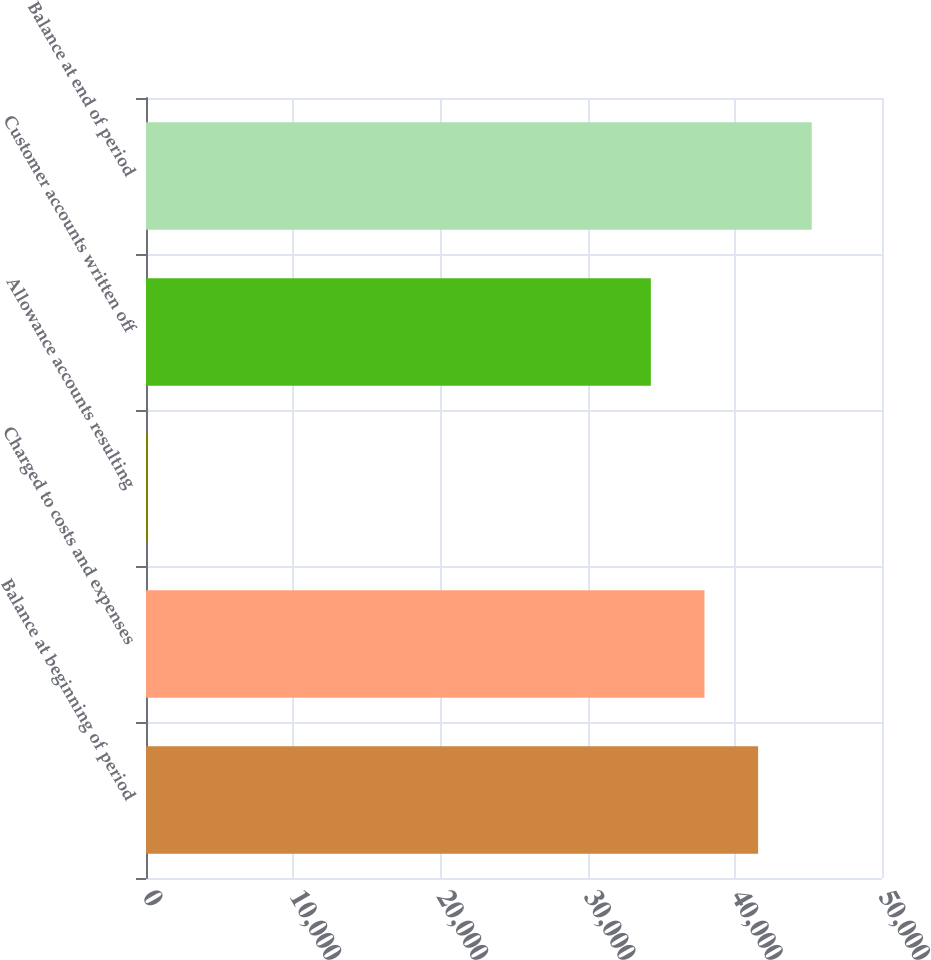<chart> <loc_0><loc_0><loc_500><loc_500><bar_chart><fcel>Balance at beginning of period<fcel>Charged to costs and expenses<fcel>Allowance accounts resulting<fcel>Customer accounts written off<fcel>Balance at end of period<nl><fcel>41583.8<fcel>37940.4<fcel>139<fcel>34297<fcel>45227.2<nl></chart> 